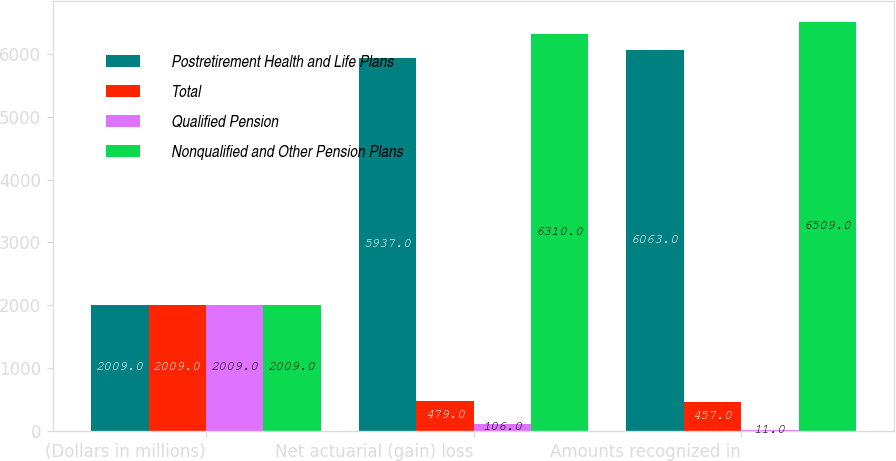Convert chart. <chart><loc_0><loc_0><loc_500><loc_500><stacked_bar_chart><ecel><fcel>(Dollars in millions)<fcel>Net actuarial (gain) loss<fcel>Amounts recognized in<nl><fcel>Postretirement Health and Life Plans<fcel>2009<fcel>5937<fcel>6063<nl><fcel>Total<fcel>2009<fcel>479<fcel>457<nl><fcel>Qualified Pension<fcel>2009<fcel>106<fcel>11<nl><fcel>Nonqualified and Other Pension Plans<fcel>2009<fcel>6310<fcel>6509<nl></chart> 